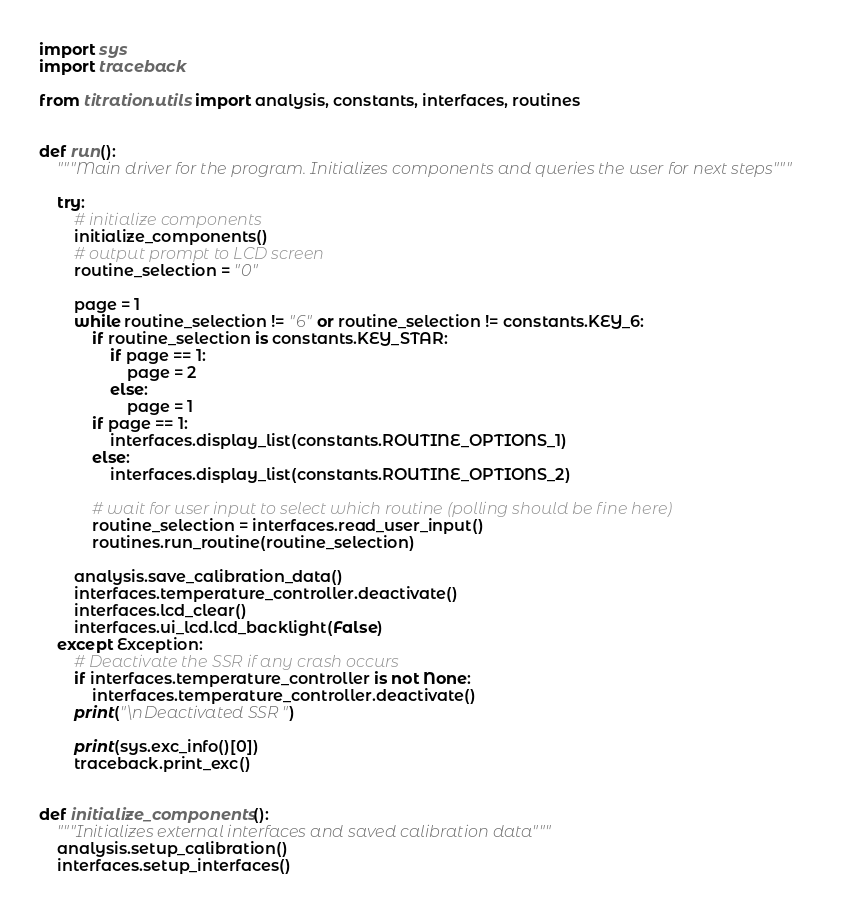<code> <loc_0><loc_0><loc_500><loc_500><_Python_>import sys
import traceback

from titration.utils import analysis, constants, interfaces, routines


def run():
    """Main driver for the program. Initializes components and queries the user for next steps"""

    try:
        # initialize components
        initialize_components()
        # output prompt to LCD screen
        routine_selection = "0"

        page = 1
        while routine_selection != "6" or routine_selection != constants.KEY_6:
            if routine_selection is constants.KEY_STAR:
                if page == 1:
                    page = 2
                else:
                    page = 1
            if page == 1:
                interfaces.display_list(constants.ROUTINE_OPTIONS_1)
            else:
                interfaces.display_list(constants.ROUTINE_OPTIONS_2)

            # wait for user input to select which routine (polling should be fine here)
            routine_selection = interfaces.read_user_input()
            routines.run_routine(routine_selection)

        analysis.save_calibration_data()
        interfaces.temperature_controller.deactivate()
        interfaces.lcd_clear()
        interfaces.ui_lcd.lcd_backlight(False)
    except Exception:
        # Deactivate the SSR if any crash occurs
        if interfaces.temperature_controller is not None:
            interfaces.temperature_controller.deactivate()
        print("\nDeactivated SSR")

        print(sys.exc_info()[0])
        traceback.print_exc()


def initialize_components():
    """Initializes external interfaces and saved calibration data"""
    analysis.setup_calibration()
    interfaces.setup_interfaces()
</code> 